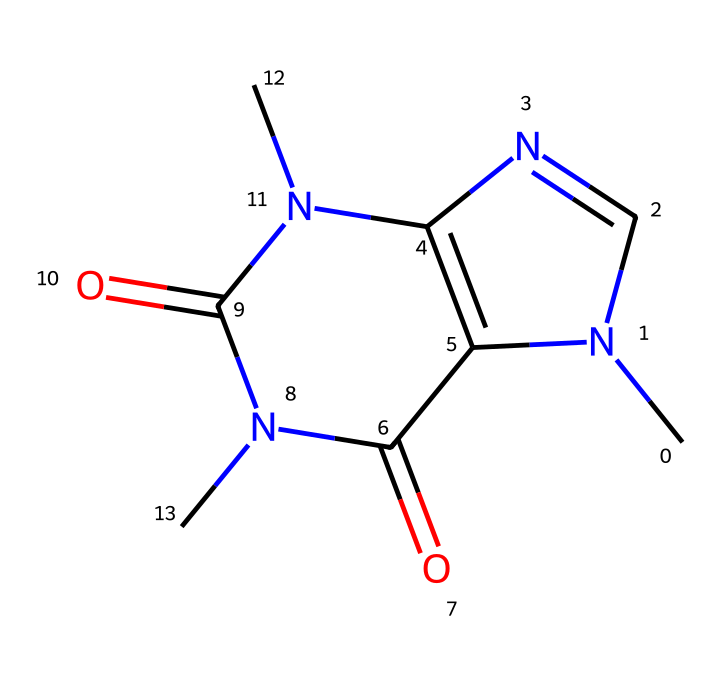What is the molecular formula of caffeine? To determine the molecular formula, we analyze the SMILES representation, counting the atoms of each element present. The structure shows a total of 8 carbon (C), 10 hydrogen (H), and 4 nitrogen (N) atoms. Therefore, the molecular formula is C8H10N4O2.
Answer: C8H10N4O2 How many rings are present in the caffeine structure? By examining the structure, we can identify that there are two distinct ring structures in caffeine. This can be seen through the interconnected atoms forming closed loops.
Answer: 2 Which type of chemical structure is depicted by this SMILES? The SMILES representation corresponds to a purine structure, which is characterized by fused ring systems that include nitrogen atoms. This indicates that caffeine falls under the purine class of alkaloids.
Answer: purine What functional groups are found in caffeine? Upon analyzing the structure, we can identify that caffeine includes both amine (-NH) and carbonyl (C=O) functional groups. The presence of these groups contributes to the chemical properties of caffeine.
Answer: amine, carbonyl What is the significance of the nitrogen atoms in caffeine's structure? The nitrogen atoms in caffeine play a crucial role in its activity as a stimulant. Their presence allows caffeine to interact with adenosine receptors in the brain, which is essential for its stimulant effects. This highlights the importance of the nitrogen atoms in defining caffeine’s pharmacological properties.
Answer: stimulant effect How does caffeine’s structure contribute to its solubility in water? Caffeine's structure has polar functional groups, specifically the nitrogen and carbonyl groups, which can interact with water molecules, increasing its solubility. The hydrogen bonding capability of these functional groups permits better solvation in aqueous environments.
Answer: polar functional groups 